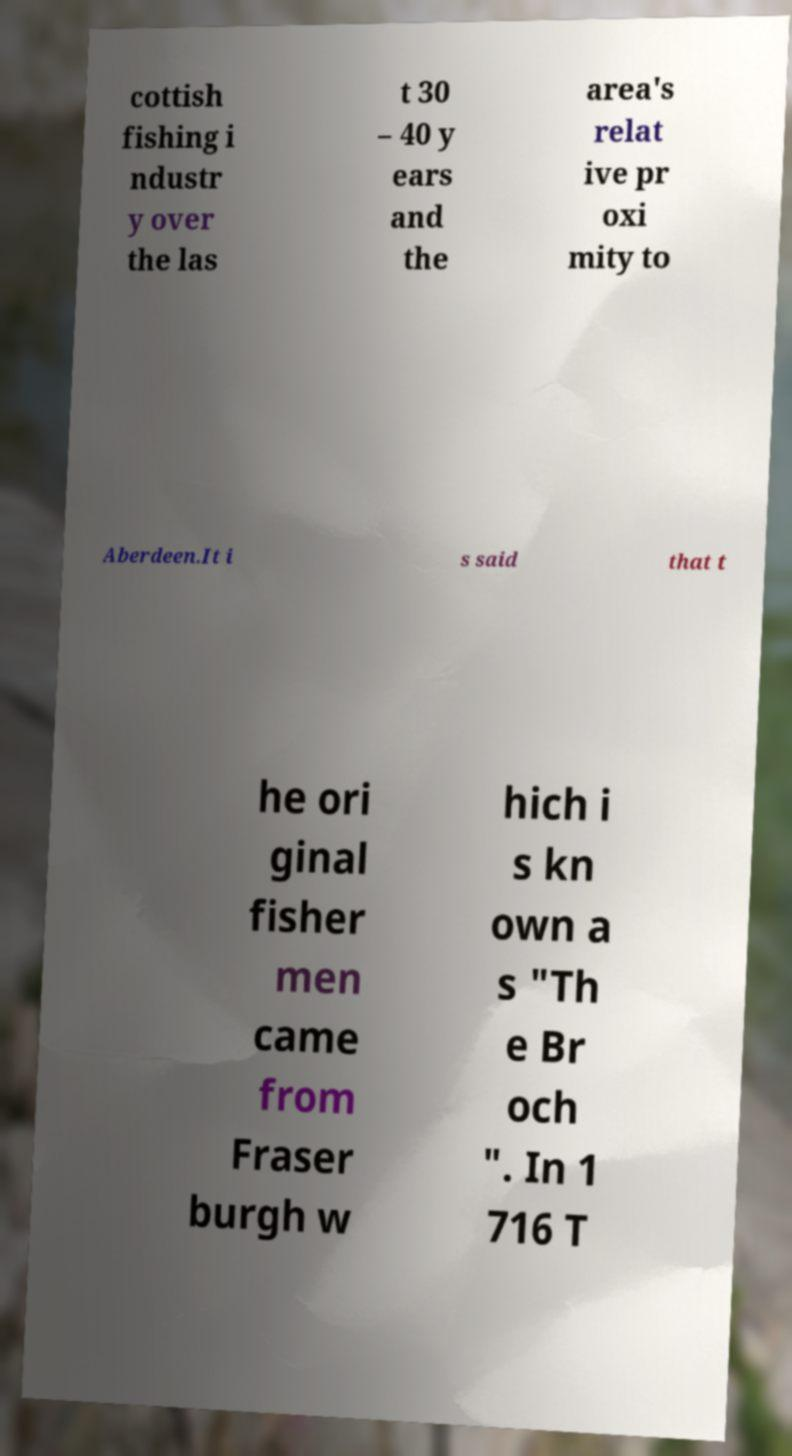Can you read and provide the text displayed in the image?This photo seems to have some interesting text. Can you extract and type it out for me? cottish fishing i ndustr y over the las t 30 – 40 y ears and the area's relat ive pr oxi mity to Aberdeen.It i s said that t he ori ginal fisher men came from Fraser burgh w hich i s kn own a s "Th e Br och ". In 1 716 T 